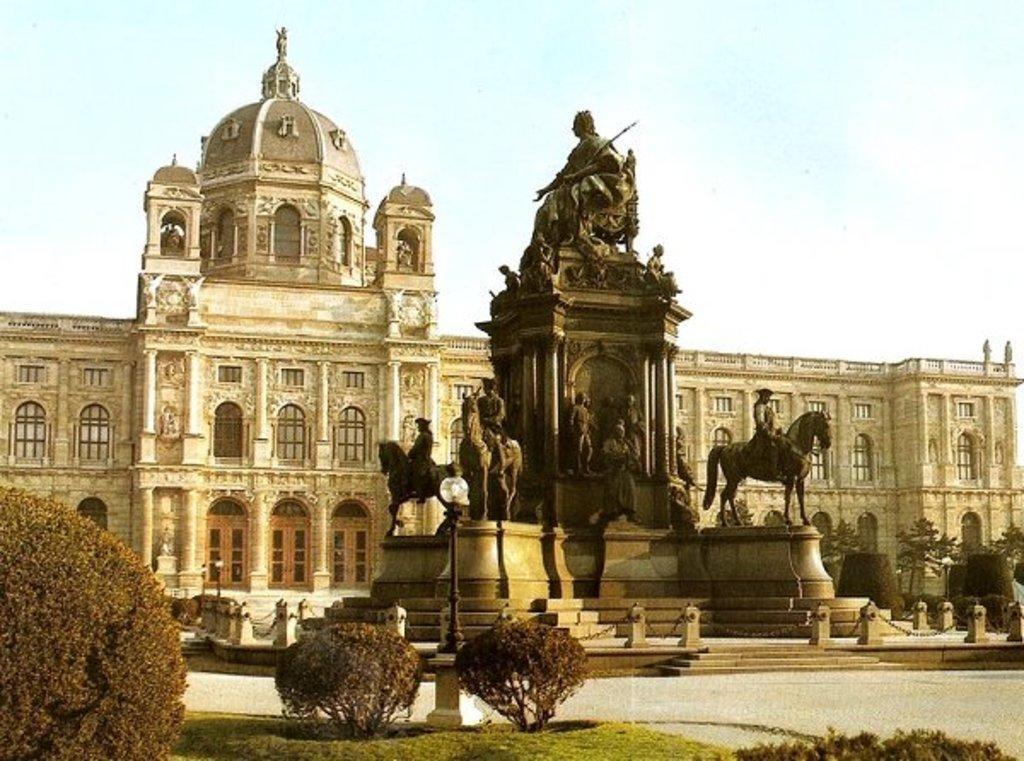How would you summarize this image in a sentence or two? In this image I can see at the bottom there are bushes. In the middle there are statues. At the back side it is a fort, at the top it is the sky. 